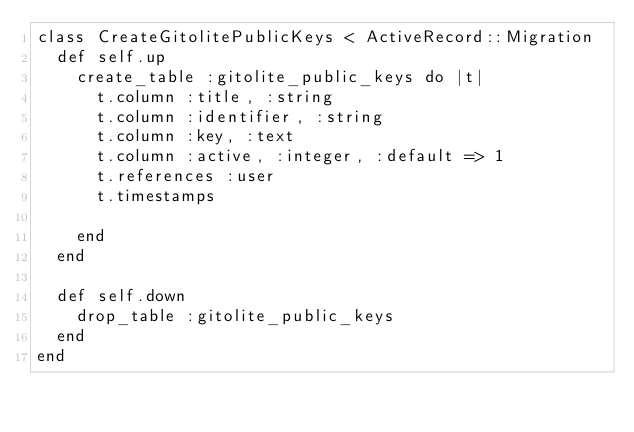Convert code to text. <code><loc_0><loc_0><loc_500><loc_500><_Ruby_>class CreateGitolitePublicKeys < ActiveRecord::Migration
  def self.up
    create_table :gitolite_public_keys do |t|
      t.column :title, :string
      t.column :identifier, :string
      t.column :key, :text
      t.column :active, :integer, :default => 1
      t.references :user
      t.timestamps
      
    end
  end

  def self.down
    drop_table :gitolite_public_keys
  end
end
</code> 